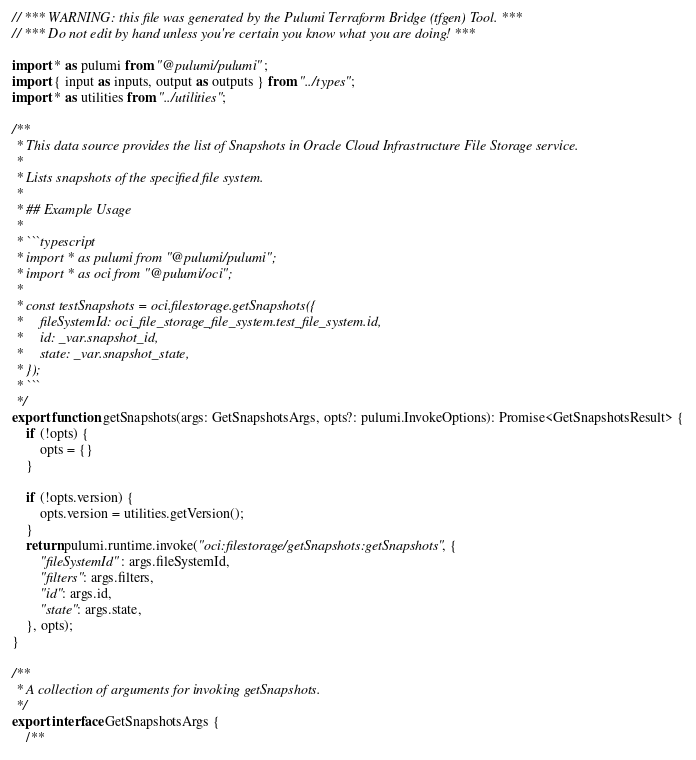<code> <loc_0><loc_0><loc_500><loc_500><_TypeScript_>// *** WARNING: this file was generated by the Pulumi Terraform Bridge (tfgen) Tool. ***
// *** Do not edit by hand unless you're certain you know what you are doing! ***

import * as pulumi from "@pulumi/pulumi";
import { input as inputs, output as outputs } from "../types";
import * as utilities from "../utilities";

/**
 * This data source provides the list of Snapshots in Oracle Cloud Infrastructure File Storage service.
 *
 * Lists snapshots of the specified file system.
 *
 * ## Example Usage
 *
 * ```typescript
 * import * as pulumi from "@pulumi/pulumi";
 * import * as oci from "@pulumi/oci";
 *
 * const testSnapshots = oci.filestorage.getSnapshots({
 *     fileSystemId: oci_file_storage_file_system.test_file_system.id,
 *     id: _var.snapshot_id,
 *     state: _var.snapshot_state,
 * });
 * ```
 */
export function getSnapshots(args: GetSnapshotsArgs, opts?: pulumi.InvokeOptions): Promise<GetSnapshotsResult> {
    if (!opts) {
        opts = {}
    }

    if (!opts.version) {
        opts.version = utilities.getVersion();
    }
    return pulumi.runtime.invoke("oci:filestorage/getSnapshots:getSnapshots", {
        "fileSystemId": args.fileSystemId,
        "filters": args.filters,
        "id": args.id,
        "state": args.state,
    }, opts);
}

/**
 * A collection of arguments for invoking getSnapshots.
 */
export interface GetSnapshotsArgs {
    /**</code> 